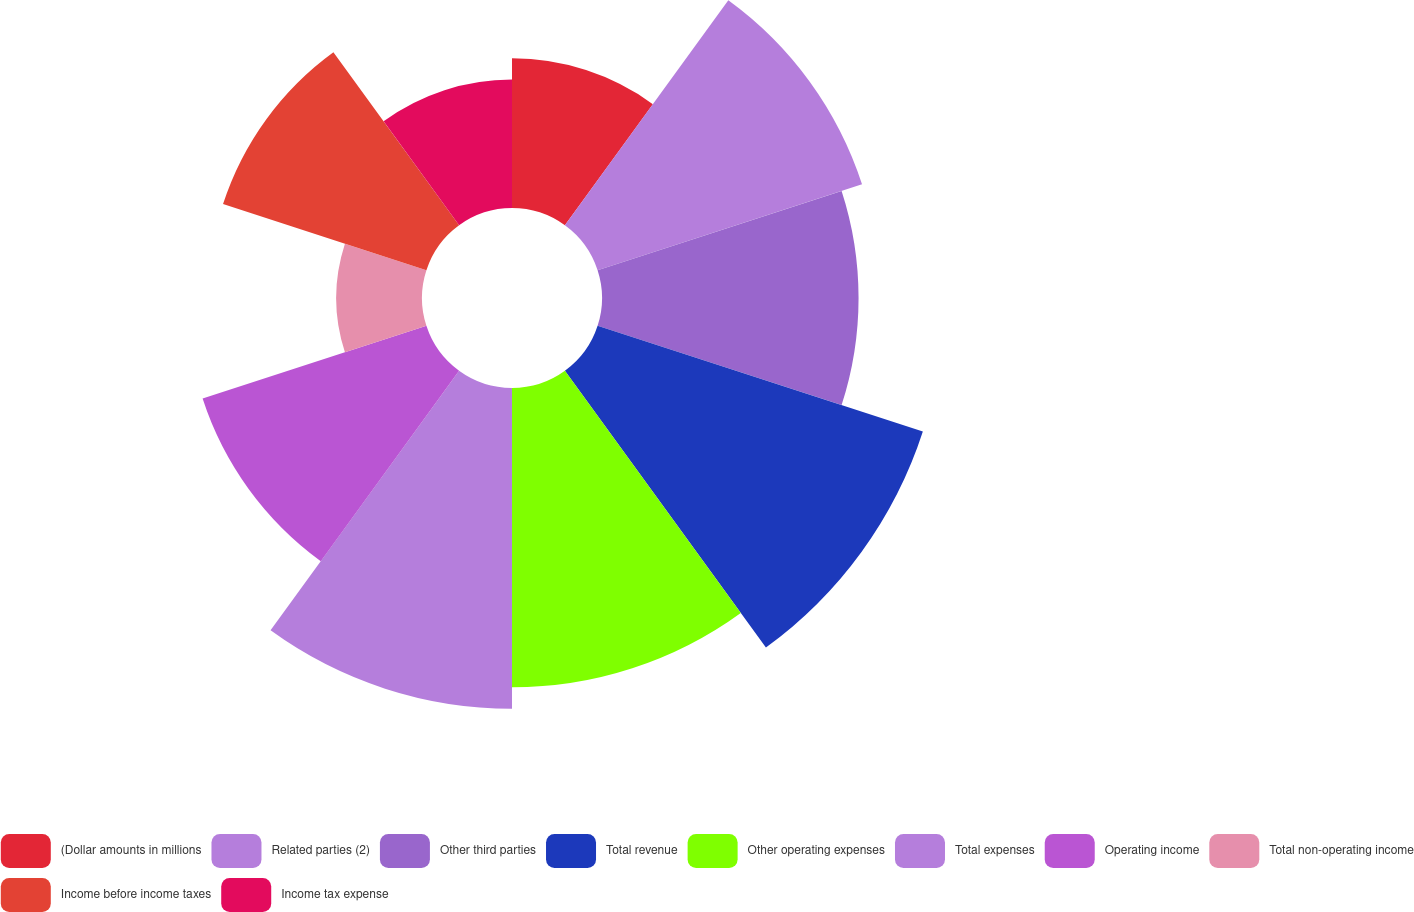Convert chart. <chart><loc_0><loc_0><loc_500><loc_500><pie_chart><fcel>(Dollar amounts in millions<fcel>Related parties (2)<fcel>Other third parties<fcel>Total revenue<fcel>Other operating expenses<fcel>Total expenses<fcel>Operating income<fcel>Total non-operating income<fcel>Income before income taxes<fcel>Income tax expense<nl><fcel>6.48%<fcel>12.04%<fcel>11.11%<fcel>14.81%<fcel>12.96%<fcel>13.89%<fcel>10.19%<fcel>3.71%<fcel>9.26%<fcel>5.56%<nl></chart> 